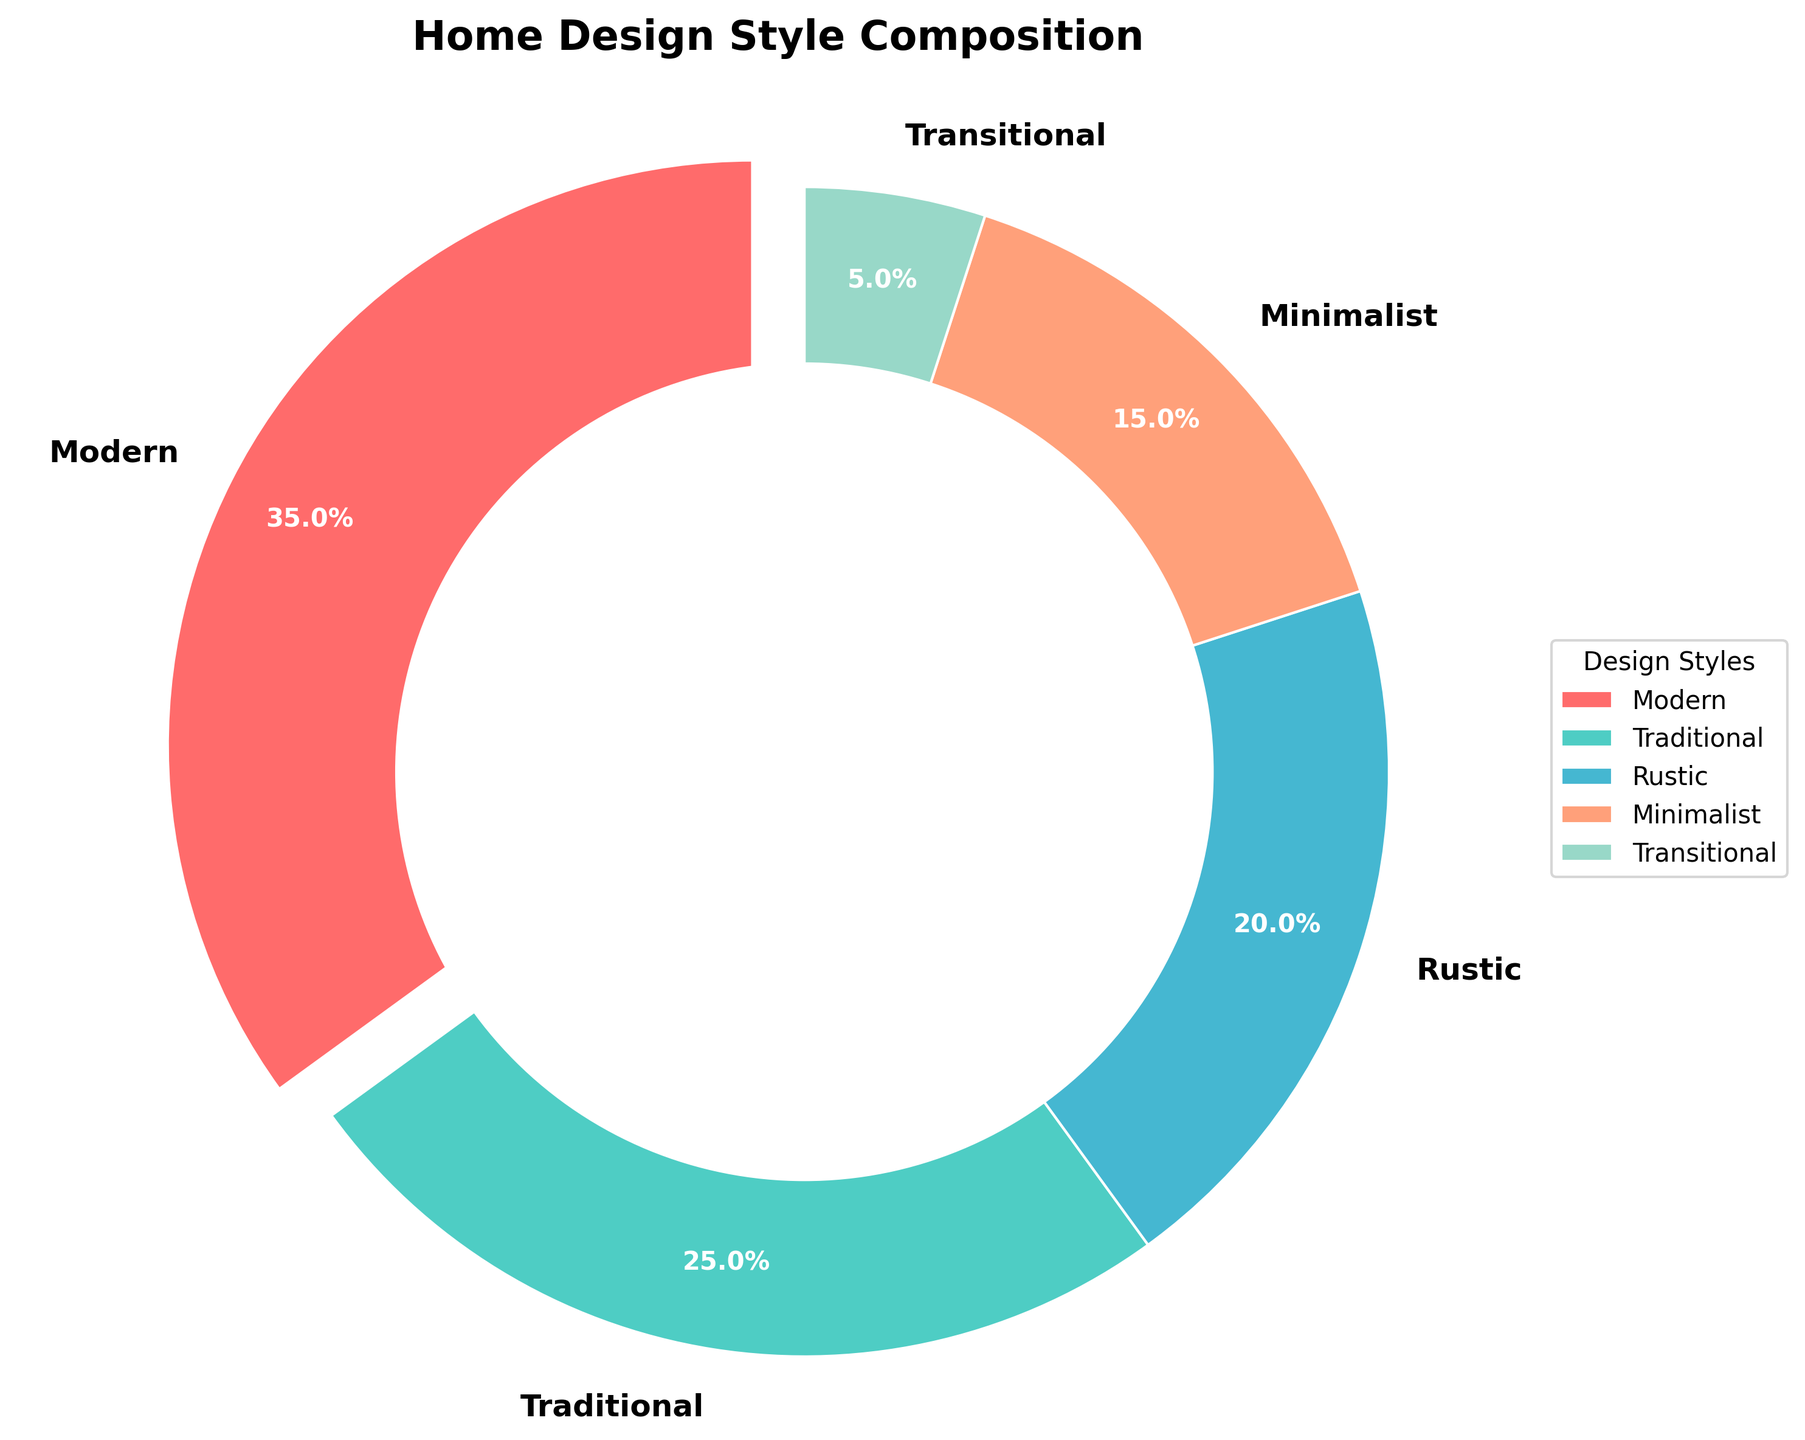What is the most common design style incorporated in the home? The pie chart shows that the 'Modern' design style has the largest section, depicting that it constitutes 35% of the total design styles incorporated.
Answer: Modern Which design styles together make up exactly half of the home's design? Combining the 'Traditional' (25%) and 'Rustic' (20%) design styles gives us a total of 45%, which is not half. Adding 'Minimalist' (15%) gives a total of 60%. To get exactly half, we need to look for another combination. Combining 'Modern' (35%) and 'Traditional' (25%) gives us exactly 60%, which means none of the combinations sum up to exactly 50%. However, the combination close to half is 'Modern' (35%) and 'Rustic' (20%) constitutes 55%.
Answer: Modern and Rustic What proportion of the home uses traditional design elements? In the pie chart, the 'Traditional' segment is labeled with a percentage of 25%, indicating the proportion of traditional design elements in the home.
Answer: 25% Which two design styles are closest in proportion? The pie chart shows 'Traditional' at 25% and 'Rustic' at 20%. These two percentages are the closest in value compared to the other percentages.
Answer: Traditional and Rustic How much more popular is the modern design style compared to the transitional design style? The pie chart indicates that 'Modern' has a proportion of 35% while 'Transitional' has 5%. To find how much more popular 'Modern' is, subtract the 'Transitional' percentage from the 'Modern' percentage. 35% - 5% = 30%.
Answer: 30% Is the sum of minimalist and rustic design styles greater than the proportion of modern design style? 'Minimalist' is 15% and 'Rustic' is 20%. Their sum is 15% + 20% = 35%. The 'Modern' design style is also 35%. Therefore, their sum is equal to the proportion of 'Modern' design style.
Answer: Equal Which design style is represented by the color blue in the chart? Observing the color scheme used in the pie chart, 'Rustic' is represented by the blue section.
Answer: Rustic What is the difference in percentage between the largest and smallest design styles incorporated in the home? The 'Modern' design style is the largest with 35%, and the 'Transitional' design style is the smallest with 5%. Subtracting the smallest from the largest gives us 35% - 5% = 30%.
Answer: 30% 